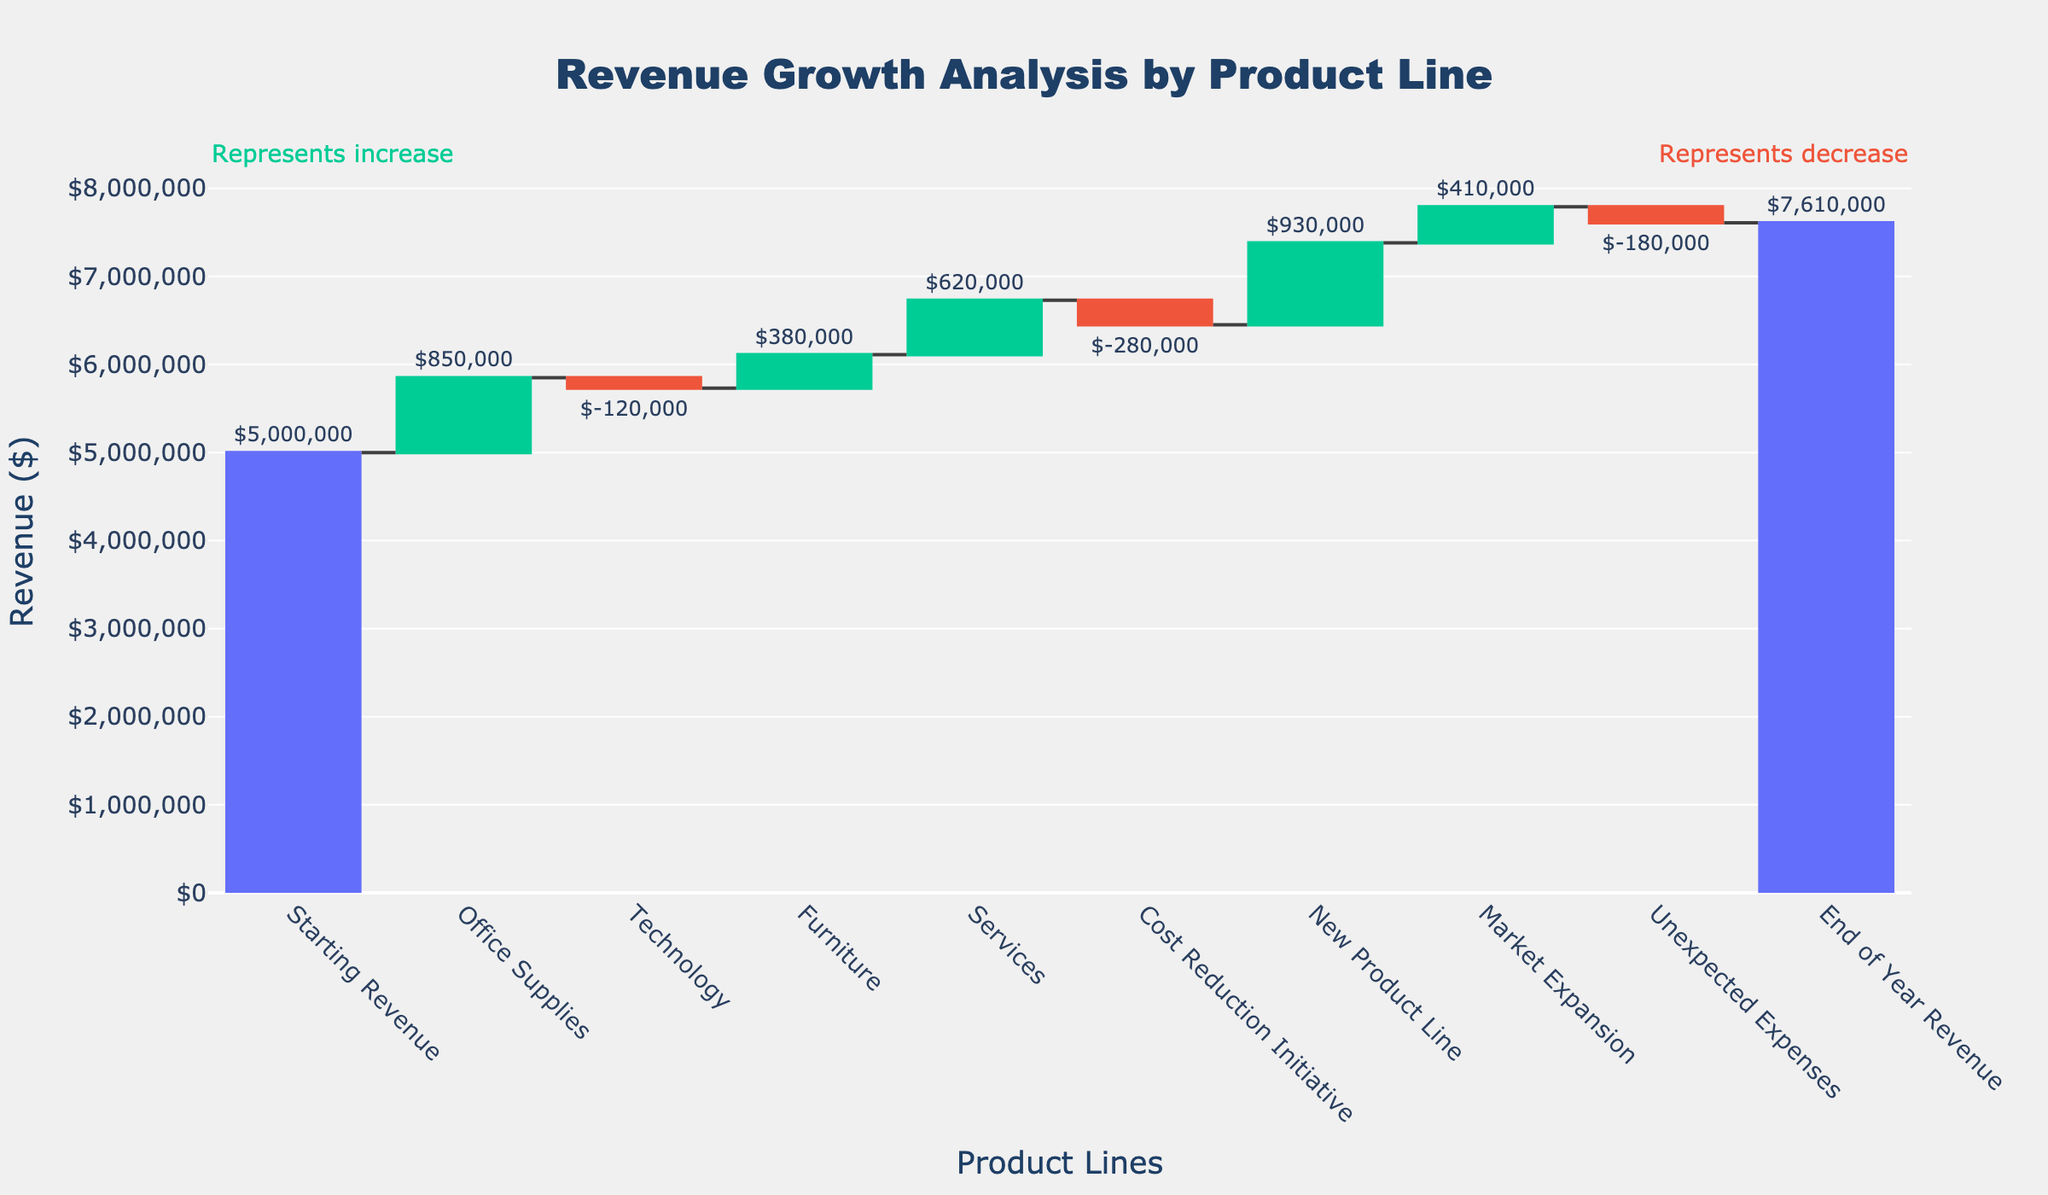How much was the starting revenue? The chart shows "Starting Revenue" at the first position with a value of $5,000,000.
Answer: $5,000,000 Which categories are shown as decreasing and what are their values? The chart uses red bars to indicate decreasing categories. The "Technology" category shows a decrease of $120,000, the "Cost Reduction Initiative" shows a decrease of $280,000, and "Unexpected Expenses" shows a decrease of $180,000.
Answer: Technology: $120,000, Cost Reduction Initiative: $280,000, Unexpected Expenses: $180,000 What is the total revenue increase attributed to positive categories excluding the starting and ending revenue? Adding up the positive values: Office Supplies ($850,000), Furniture ($380,000), Services ($620,000), New Product Line ($930,000), Market Expansion ($410,000): $850,000 + $380,000 + $620,000 + $930,000 + $410,000 = $3,190,000
Answer: $3,190,000 How does the end of year revenue compare to the starting revenue? The starting revenue is $5,000,000 and the end of year revenue is $7,610,000. The difference is $7,610,000 - $5,000,000 = $2,610,000.
Answer: $2,610,000 more Which category contributed the most to the revenue growth? Among the increasing categories, "New Product Line" had the highest positive value of $930,000.
Answer: New Product Line What is the net impact of the "Technology" and "Cost Reduction Initiative" categories on the revenue? Both categories are shown as decreasing. Adding their negative impacts together: -$120,000 (Technology) + -$280,000 (Cost Reduction Initiative) = -$400,000.
Answer: -$400,000 How much revenue was added by "Market Expansion"? The "Market Expansion" category shows an increase and adds $410,000 to the revenue.
Answer: $410,000 What is the sum of all expenses categorized under decreasing categories? Adding all the decreasing values: $120,000 (Technology) + $280,000 (Cost Reduction Initiative) + $180,000 (Unexpected Expenses) = $580,000.
Answer: $580,000 Explain how the end-of-year revenue is calculated step-by-step based on the chart data. Starting revenue is $5,000,000. Add increases: Office Supplies ($850,000), Furniture ($380,000), Services ($620,000), New Product Line ($930,000), Market Expansion ($410,000). Subtract decreases: Technology (-$120,000), Cost Reduction Initiative (-$280,000), Unexpected Expenses (-$180,000). Sum is: $5,000,000 + $850,000 + $380,000 + $620,000 + $930,000 + $410,000 - $120,000 - $280,000 - $180,000 = $7,610,000.
Answer: $7,610,000 